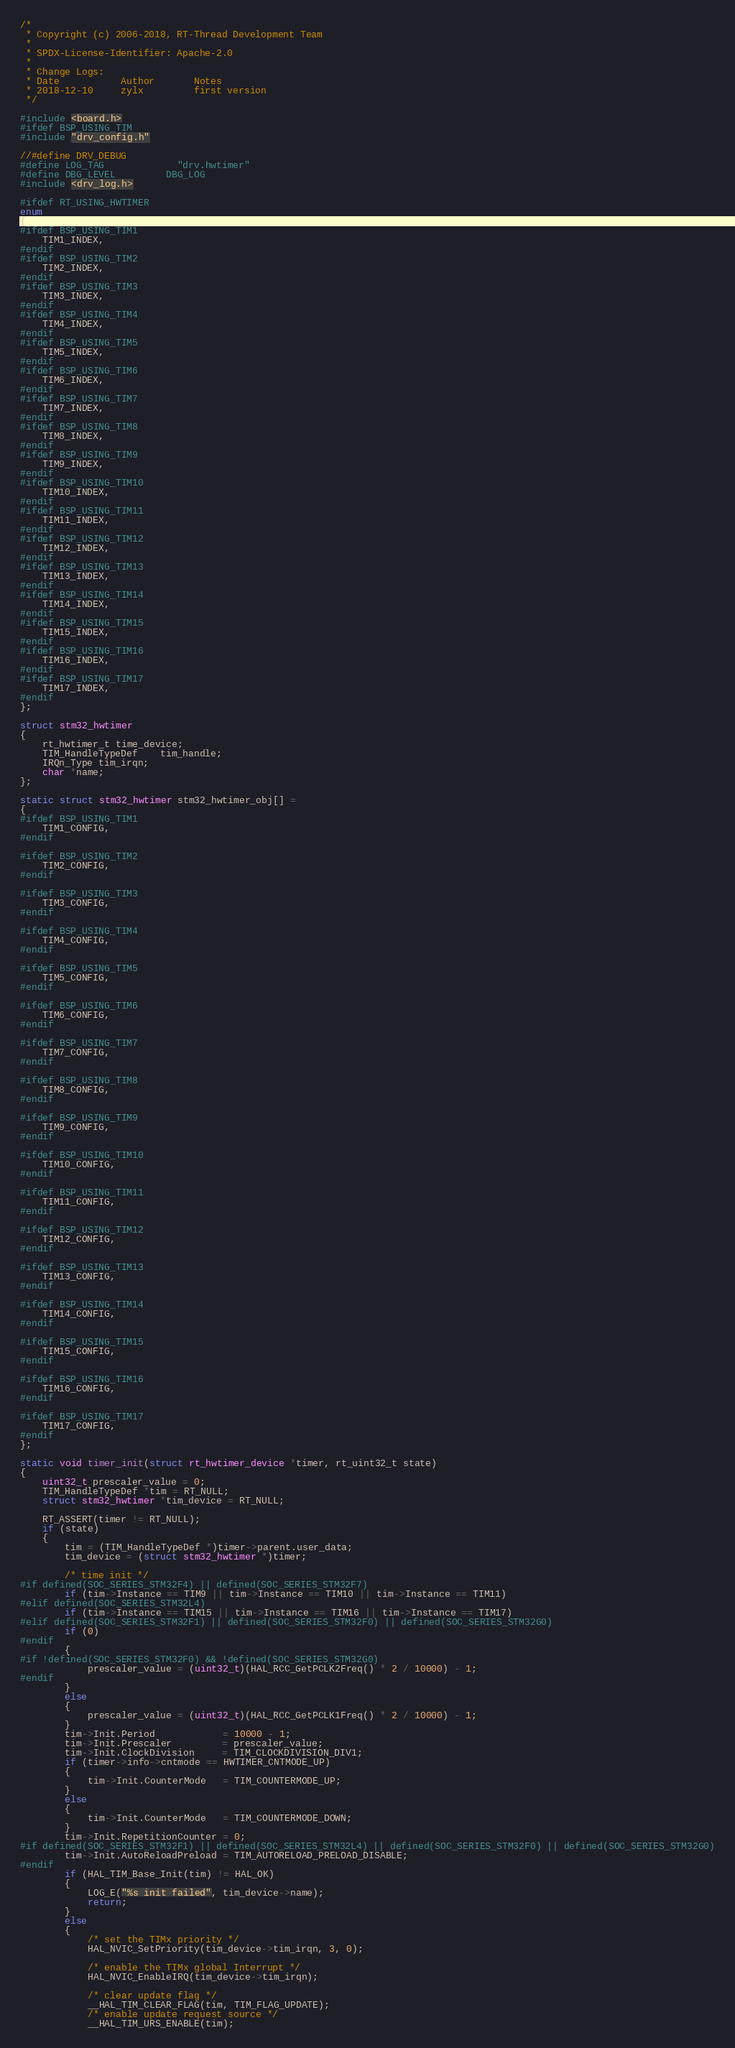Convert code to text. <code><loc_0><loc_0><loc_500><loc_500><_C_>/*
 * Copyright (c) 2006-2018, RT-Thread Development Team
 *
 * SPDX-License-Identifier: Apache-2.0
 *
 * Change Logs:
 * Date           Author       Notes
 * 2018-12-10     zylx         first version
 */

#include <board.h>
#ifdef BSP_USING_TIM
#include "drv_config.h"

//#define DRV_DEBUG
#define LOG_TAG             "drv.hwtimer"
#define DBG_LEVEL         DBG_LOG
#include <drv_log.h>

#ifdef RT_USING_HWTIMER
enum
{
#ifdef BSP_USING_TIM1
    TIM1_INDEX,
#endif
#ifdef BSP_USING_TIM2
    TIM2_INDEX,
#endif
#ifdef BSP_USING_TIM3
    TIM3_INDEX,
#endif
#ifdef BSP_USING_TIM4
    TIM4_INDEX,
#endif
#ifdef BSP_USING_TIM5
    TIM5_INDEX,
#endif
#ifdef BSP_USING_TIM6
    TIM6_INDEX,
#endif
#ifdef BSP_USING_TIM7
    TIM7_INDEX,
#endif
#ifdef BSP_USING_TIM8
    TIM8_INDEX,
#endif
#ifdef BSP_USING_TIM9
    TIM9_INDEX,
#endif
#ifdef BSP_USING_TIM10
    TIM10_INDEX,
#endif
#ifdef BSP_USING_TIM11
    TIM11_INDEX,
#endif
#ifdef BSP_USING_TIM12
    TIM12_INDEX,
#endif
#ifdef BSP_USING_TIM13
    TIM13_INDEX,
#endif
#ifdef BSP_USING_TIM14
    TIM14_INDEX,
#endif
#ifdef BSP_USING_TIM15
    TIM15_INDEX,
#endif
#ifdef BSP_USING_TIM16
    TIM16_INDEX,
#endif
#ifdef BSP_USING_TIM17
    TIM17_INDEX,
#endif
};

struct stm32_hwtimer
{
    rt_hwtimer_t time_device;
    TIM_HandleTypeDef    tim_handle;
    IRQn_Type tim_irqn;
    char *name;
};

static struct stm32_hwtimer stm32_hwtimer_obj[] =
{
#ifdef BSP_USING_TIM1
    TIM1_CONFIG,
#endif

#ifdef BSP_USING_TIM2
    TIM2_CONFIG,
#endif

#ifdef BSP_USING_TIM3
    TIM3_CONFIG,
#endif

#ifdef BSP_USING_TIM4
    TIM4_CONFIG,
#endif

#ifdef BSP_USING_TIM5
    TIM5_CONFIG,
#endif

#ifdef BSP_USING_TIM6
    TIM6_CONFIG,
#endif

#ifdef BSP_USING_TIM7
    TIM7_CONFIG,
#endif

#ifdef BSP_USING_TIM8
    TIM8_CONFIG,
#endif

#ifdef BSP_USING_TIM9
    TIM9_CONFIG,
#endif

#ifdef BSP_USING_TIM10
    TIM10_CONFIG,
#endif

#ifdef BSP_USING_TIM11
    TIM11_CONFIG,
#endif

#ifdef BSP_USING_TIM12
    TIM12_CONFIG,
#endif

#ifdef BSP_USING_TIM13
    TIM13_CONFIG,
#endif

#ifdef BSP_USING_TIM14
    TIM14_CONFIG,
#endif

#ifdef BSP_USING_TIM15
    TIM15_CONFIG,
#endif

#ifdef BSP_USING_TIM16
    TIM16_CONFIG,
#endif

#ifdef BSP_USING_TIM17
    TIM17_CONFIG,
#endif
};

static void timer_init(struct rt_hwtimer_device *timer, rt_uint32_t state)
{
    uint32_t prescaler_value = 0;
    TIM_HandleTypeDef *tim = RT_NULL;
    struct stm32_hwtimer *tim_device = RT_NULL;

    RT_ASSERT(timer != RT_NULL);
    if (state)
    {
        tim = (TIM_HandleTypeDef *)timer->parent.user_data;
        tim_device = (struct stm32_hwtimer *)timer;

        /* time init */
#if defined(SOC_SERIES_STM32F4) || defined(SOC_SERIES_STM32F7)
        if (tim->Instance == TIM9 || tim->Instance == TIM10 || tim->Instance == TIM11)
#elif defined(SOC_SERIES_STM32L4)
        if (tim->Instance == TIM15 || tim->Instance == TIM16 || tim->Instance == TIM17)
#elif defined(SOC_SERIES_STM32F1) || defined(SOC_SERIES_STM32F0) || defined(SOC_SERIES_STM32G0)
        if (0)
#endif
        {
#if !defined(SOC_SERIES_STM32F0) && !defined(SOC_SERIES_STM32G0)
            prescaler_value = (uint32_t)(HAL_RCC_GetPCLK2Freq() * 2 / 10000) - 1;
#endif
        }
        else
        {
            prescaler_value = (uint32_t)(HAL_RCC_GetPCLK1Freq() * 2 / 10000) - 1;
        }
        tim->Init.Period            = 10000 - 1;
        tim->Init.Prescaler         = prescaler_value;
        tim->Init.ClockDivision     = TIM_CLOCKDIVISION_DIV1;
        if (timer->info->cntmode == HWTIMER_CNTMODE_UP)
        {
            tim->Init.CounterMode   = TIM_COUNTERMODE_UP;
        }
        else
        {
            tim->Init.CounterMode   = TIM_COUNTERMODE_DOWN;
        }
        tim->Init.RepetitionCounter = 0;
#if defined(SOC_SERIES_STM32F1) || defined(SOC_SERIES_STM32L4) || defined(SOC_SERIES_STM32F0) || defined(SOC_SERIES_STM32G0)
        tim->Init.AutoReloadPreload = TIM_AUTORELOAD_PRELOAD_DISABLE;
#endif
        if (HAL_TIM_Base_Init(tim) != HAL_OK)
        {
            LOG_E("%s init failed", tim_device->name);
            return;
        }
        else
        {
            /* set the TIMx priority */
            HAL_NVIC_SetPriority(tim_device->tim_irqn, 3, 0);

            /* enable the TIMx global Interrupt */
            HAL_NVIC_EnableIRQ(tim_device->tim_irqn);

            /* clear update flag */
            __HAL_TIM_CLEAR_FLAG(tim, TIM_FLAG_UPDATE);
            /* enable update request source */
            __HAL_TIM_URS_ENABLE(tim);
</code> 